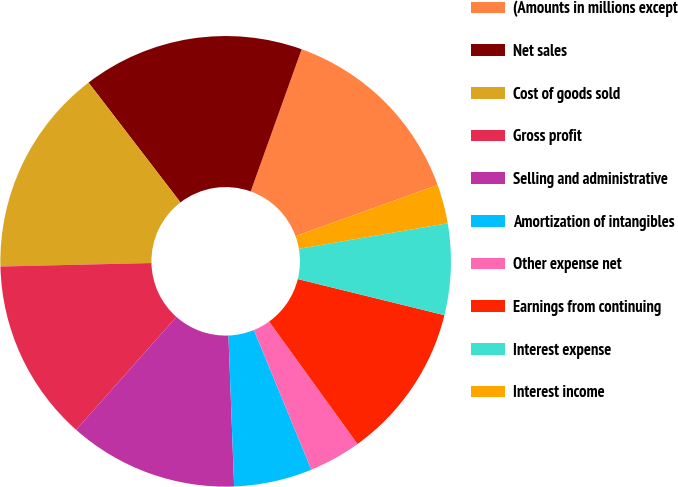Convert chart to OTSL. <chart><loc_0><loc_0><loc_500><loc_500><pie_chart><fcel>(Amounts in millions except<fcel>Net sales<fcel>Cost of goods sold<fcel>Gross profit<fcel>Selling and administrative<fcel>Amortization of intangibles<fcel>Other expense net<fcel>Earnings from continuing<fcel>Interest expense<fcel>Interest income<nl><fcel>14.02%<fcel>15.89%<fcel>14.95%<fcel>13.08%<fcel>12.15%<fcel>5.61%<fcel>3.74%<fcel>11.21%<fcel>6.54%<fcel>2.8%<nl></chart> 